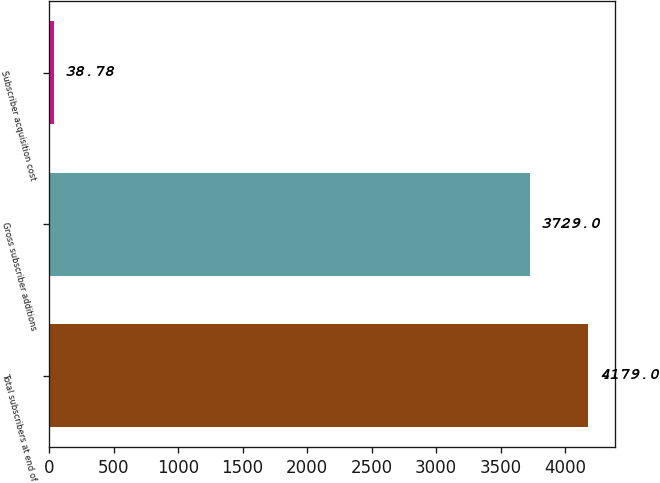Convert chart to OTSL. <chart><loc_0><loc_0><loc_500><loc_500><bar_chart><fcel>Total subscribers at end of<fcel>Gross subscriber additions<fcel>Subscriber acquisition cost<nl><fcel>4179<fcel>3729<fcel>38.78<nl></chart> 